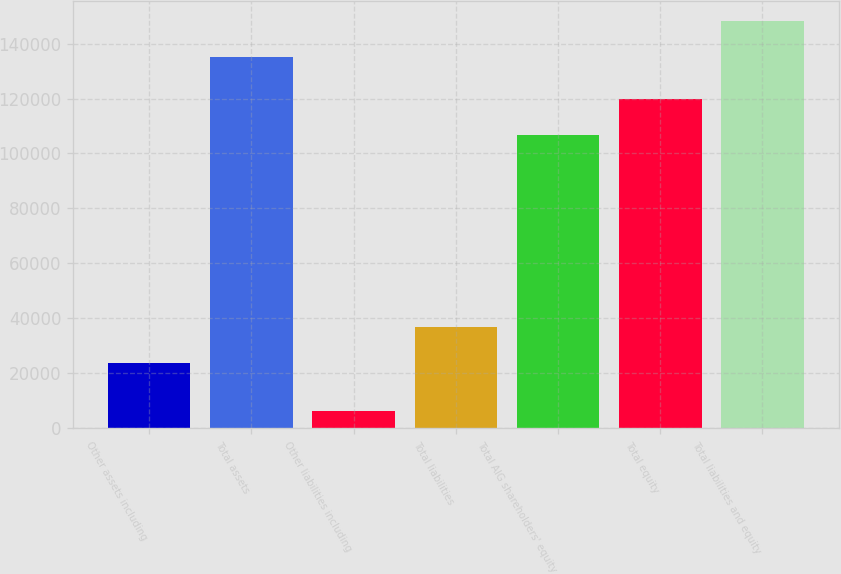Convert chart. <chart><loc_0><loc_0><loc_500><loc_500><bar_chart><fcel>Other assets including<fcel>Total assets<fcel>Other liabilities including<fcel>Total liabilities<fcel>Total AIG shareholders' equity<fcel>Total equity<fcel>Total liabilities and equity<nl><fcel>23835<fcel>135235<fcel>6196<fcel>36738.9<fcel>106898<fcel>119802<fcel>148139<nl></chart> 